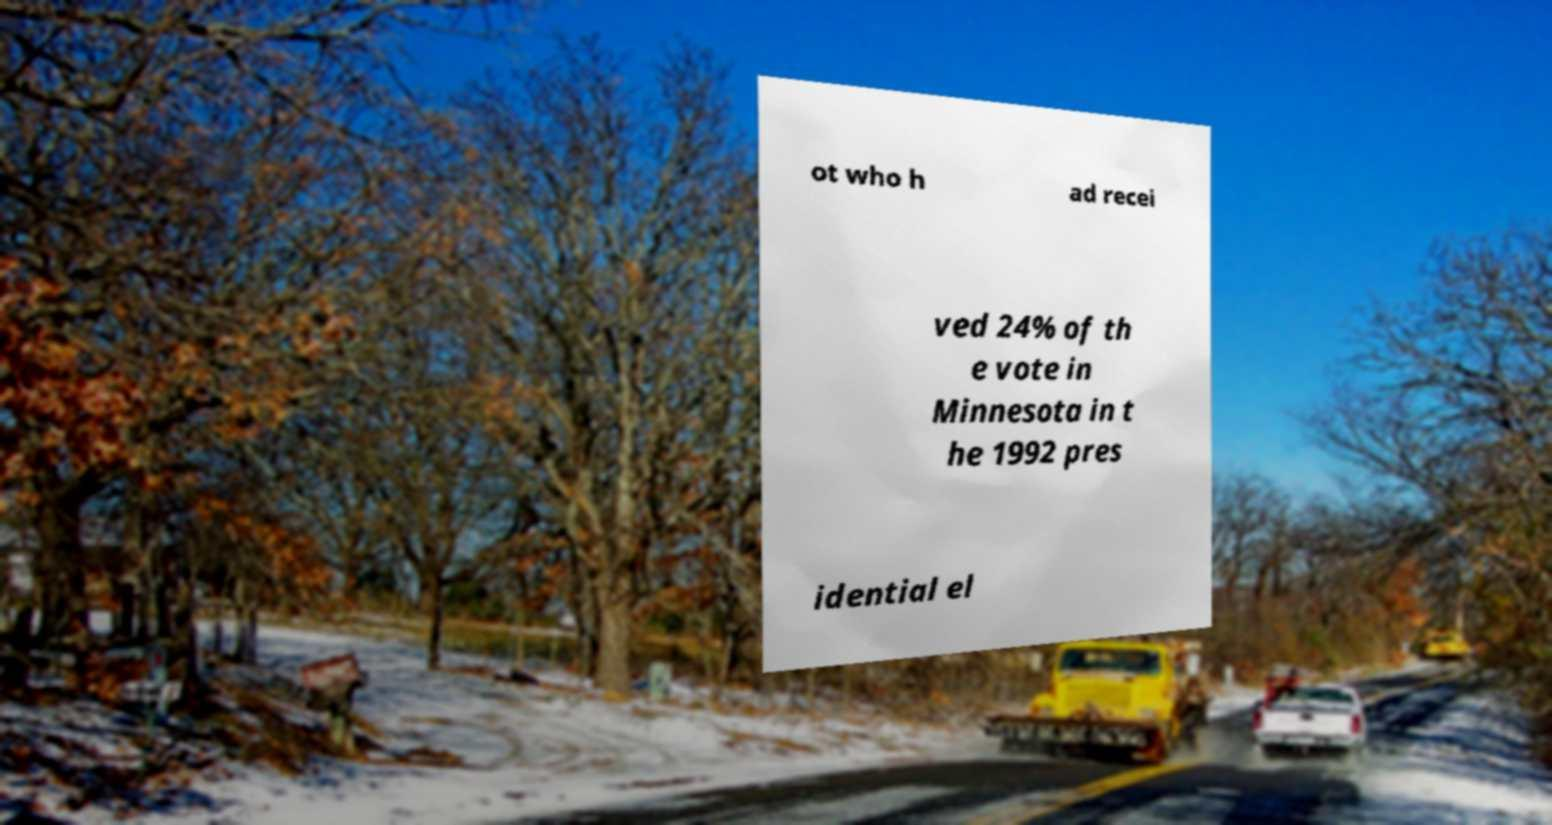Can you accurately transcribe the text from the provided image for me? ot who h ad recei ved 24% of th e vote in Minnesota in t he 1992 pres idential el 